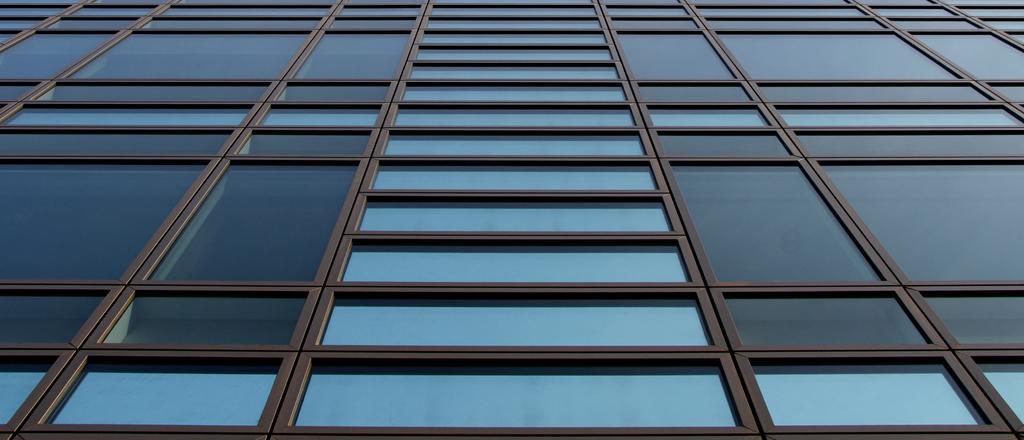How would you summarize this image in a sentence or two? In this picture, it looks like a building with glasses and iron rods. 